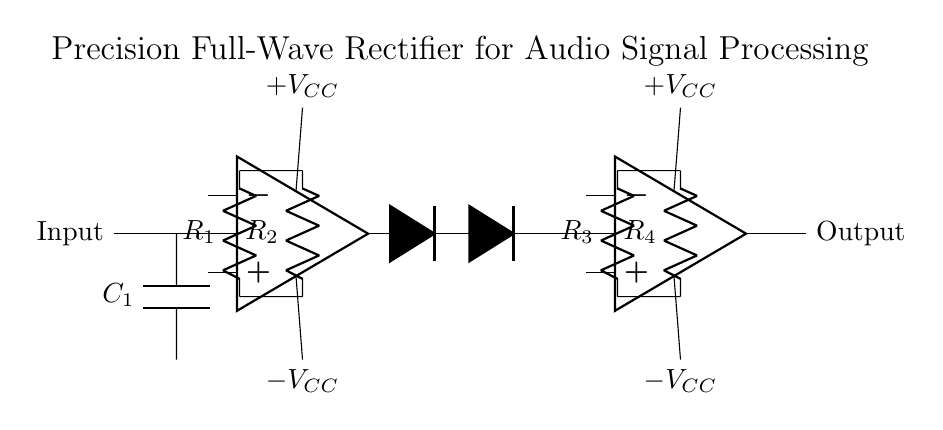What does the capacitor in this circuit do? The capacitor, labeled C1, is connected in parallel with the input signal. In a precision rectifier, capacitors help to filter and smooth the input signal, ensuring that transients do not affect the rectification process.
Answer: Smoothing input What are the resistance values used in this circuit? The circuit has four resistors labeled R1, R2, R3, and R4. Their values can usually be indicated numerically, but they are not specified in the drawn circuit. Thus, you can look at the schematic and typically assume values understandable in context.
Answer: Not specified How many operational amplifiers are used in this circuit? The circuit diagram includes two operational amplifiers, as indicated by the two op-amp symbols drawn. Each serves a role in the rectification process, enhancing linearity and precision.
Answer: Two What type of rectification does this circuit perform? The arrangement of diodes and op-amps indicates that this circuit performs full-wave rectification, as both the positive and negative halves of the input waveform are utilized to produce a single-direction output.
Answer: Full-wave What is the purpose of the diodes in this circuit? The diodes serve to allow current to flow in only one direction during the rectification process, ensuring that when the input signal goes negative, the op-amps invert it, effectively providing a full-wave rectification by transforming both halves of the input into positive output.
Answer: Rectification 